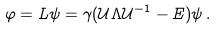Convert formula to latex. <formula><loc_0><loc_0><loc_500><loc_500>\varphi = L \psi = \gamma ( { \mathcal { U } } \Lambda { \mathcal { U } } ^ { - 1 } - E ) \psi \, .</formula> 